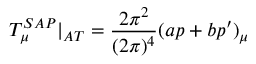<formula> <loc_0><loc_0><loc_500><loc_500>T _ { \mu } ^ { S A P } | _ { A T } = \frac { 2 \pi ^ { 2 } } { ( 2 \pi ) ^ { 4 } } ( a p + b p ^ { \prime } ) _ { \mu }</formula> 